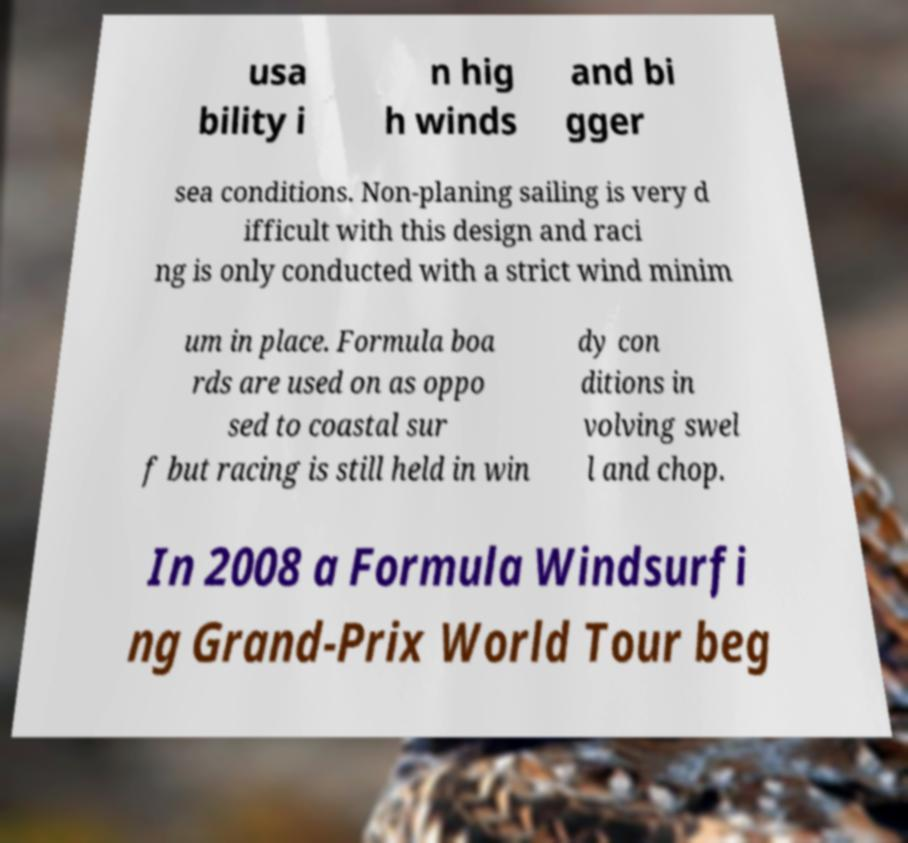What messages or text are displayed in this image? I need them in a readable, typed format. usa bility i n hig h winds and bi gger sea conditions. Non-planing sailing is very d ifficult with this design and raci ng is only conducted with a strict wind minim um in place. Formula boa rds are used on as oppo sed to coastal sur f but racing is still held in win dy con ditions in volving swel l and chop. In 2008 a Formula Windsurfi ng Grand-Prix World Tour beg 